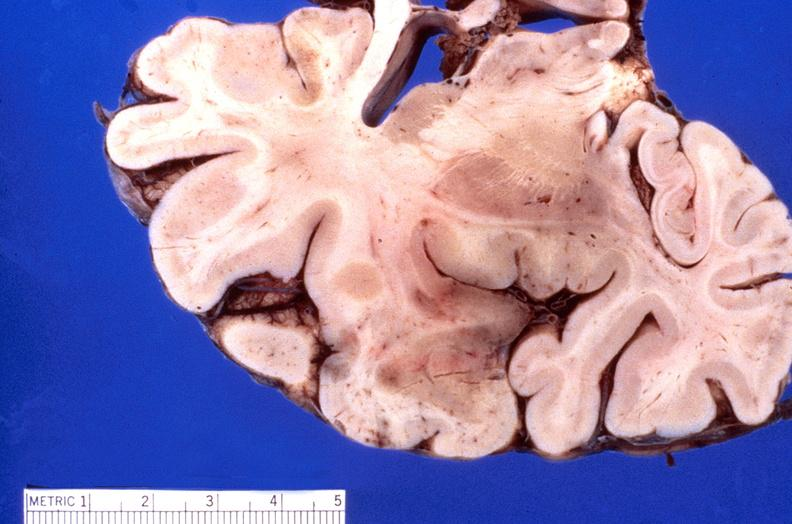s nervous present?
Answer the question using a single word or phrase. Yes 